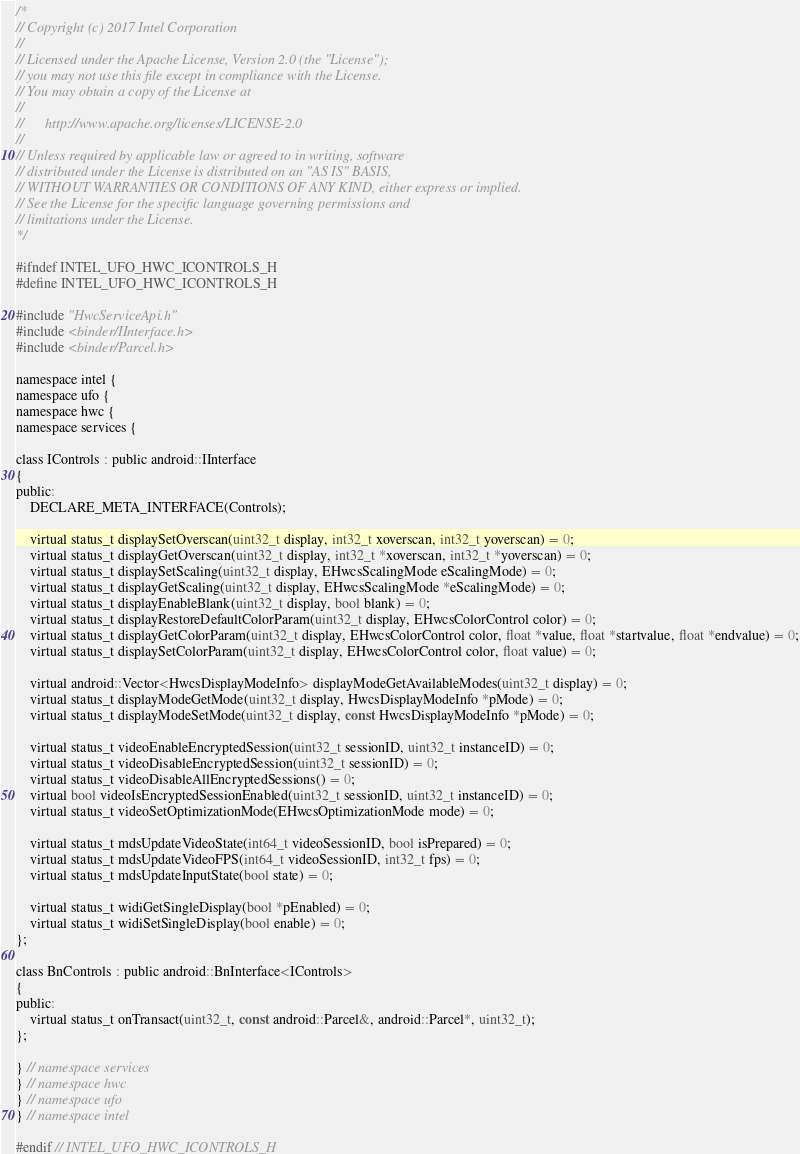Convert code to text. <code><loc_0><loc_0><loc_500><loc_500><_C_>/*
// Copyright (c) 2017 Intel Corporation
//
// Licensed under the Apache License, Version 2.0 (the "License");
// you may not use this file except in compliance with the License.
// You may obtain a copy of the License at
//
//      http://www.apache.org/licenses/LICENSE-2.0
//
// Unless required by applicable law or agreed to in writing, software
// distributed under the License is distributed on an "AS IS" BASIS,
// WITHOUT WARRANTIES OR CONDITIONS OF ANY KIND, either express or implied.
// See the License for the specific language governing permissions and
// limitations under the License.
*/

#ifndef INTEL_UFO_HWC_ICONTROLS_H
#define INTEL_UFO_HWC_ICONTROLS_H

#include "HwcServiceApi.h"
#include <binder/IInterface.h>
#include <binder/Parcel.h>

namespace intel {
namespace ufo {
namespace hwc {
namespace services {

class IControls : public android::IInterface
{
public:
    DECLARE_META_INTERFACE(Controls);

    virtual status_t displaySetOverscan(uint32_t display, int32_t xoverscan, int32_t yoverscan) = 0;
    virtual status_t displayGetOverscan(uint32_t display, int32_t *xoverscan, int32_t *yoverscan) = 0;
    virtual status_t displaySetScaling(uint32_t display, EHwcsScalingMode eScalingMode) = 0;
    virtual status_t displayGetScaling(uint32_t display, EHwcsScalingMode *eScalingMode) = 0;
    virtual status_t displayEnableBlank(uint32_t display, bool blank) = 0;
    virtual status_t displayRestoreDefaultColorParam(uint32_t display, EHwcsColorControl color) = 0;
    virtual status_t displayGetColorParam(uint32_t display, EHwcsColorControl color, float *value, float *startvalue, float *endvalue) = 0;
    virtual status_t displaySetColorParam(uint32_t display, EHwcsColorControl color, float value) = 0;

    virtual android::Vector<HwcsDisplayModeInfo> displayModeGetAvailableModes(uint32_t display) = 0;
    virtual status_t displayModeGetMode(uint32_t display, HwcsDisplayModeInfo *pMode) = 0;
    virtual status_t displayModeSetMode(uint32_t display, const HwcsDisplayModeInfo *pMode) = 0;

    virtual status_t videoEnableEncryptedSession(uint32_t sessionID, uint32_t instanceID) = 0;
    virtual status_t videoDisableEncryptedSession(uint32_t sessionID) = 0;
    virtual status_t videoDisableAllEncryptedSessions() = 0;
    virtual bool videoIsEncryptedSessionEnabled(uint32_t sessionID, uint32_t instanceID) = 0;
    virtual status_t videoSetOptimizationMode(EHwcsOptimizationMode mode) = 0;

    virtual status_t mdsUpdateVideoState(int64_t videoSessionID, bool isPrepared) = 0;
    virtual status_t mdsUpdateVideoFPS(int64_t videoSessionID, int32_t fps) = 0;
    virtual status_t mdsUpdateInputState(bool state) = 0;

    virtual status_t widiGetSingleDisplay(bool *pEnabled) = 0;
    virtual status_t widiSetSingleDisplay(bool enable) = 0;
};

class BnControls : public android::BnInterface<IControls>
{
public:
    virtual status_t onTransact(uint32_t, const android::Parcel&, android::Parcel*, uint32_t);
};

} // namespace services
} // namespace hwc
} // namespace ufo
} // namespace intel

#endif // INTEL_UFO_HWC_ICONTROLS_H
</code> 